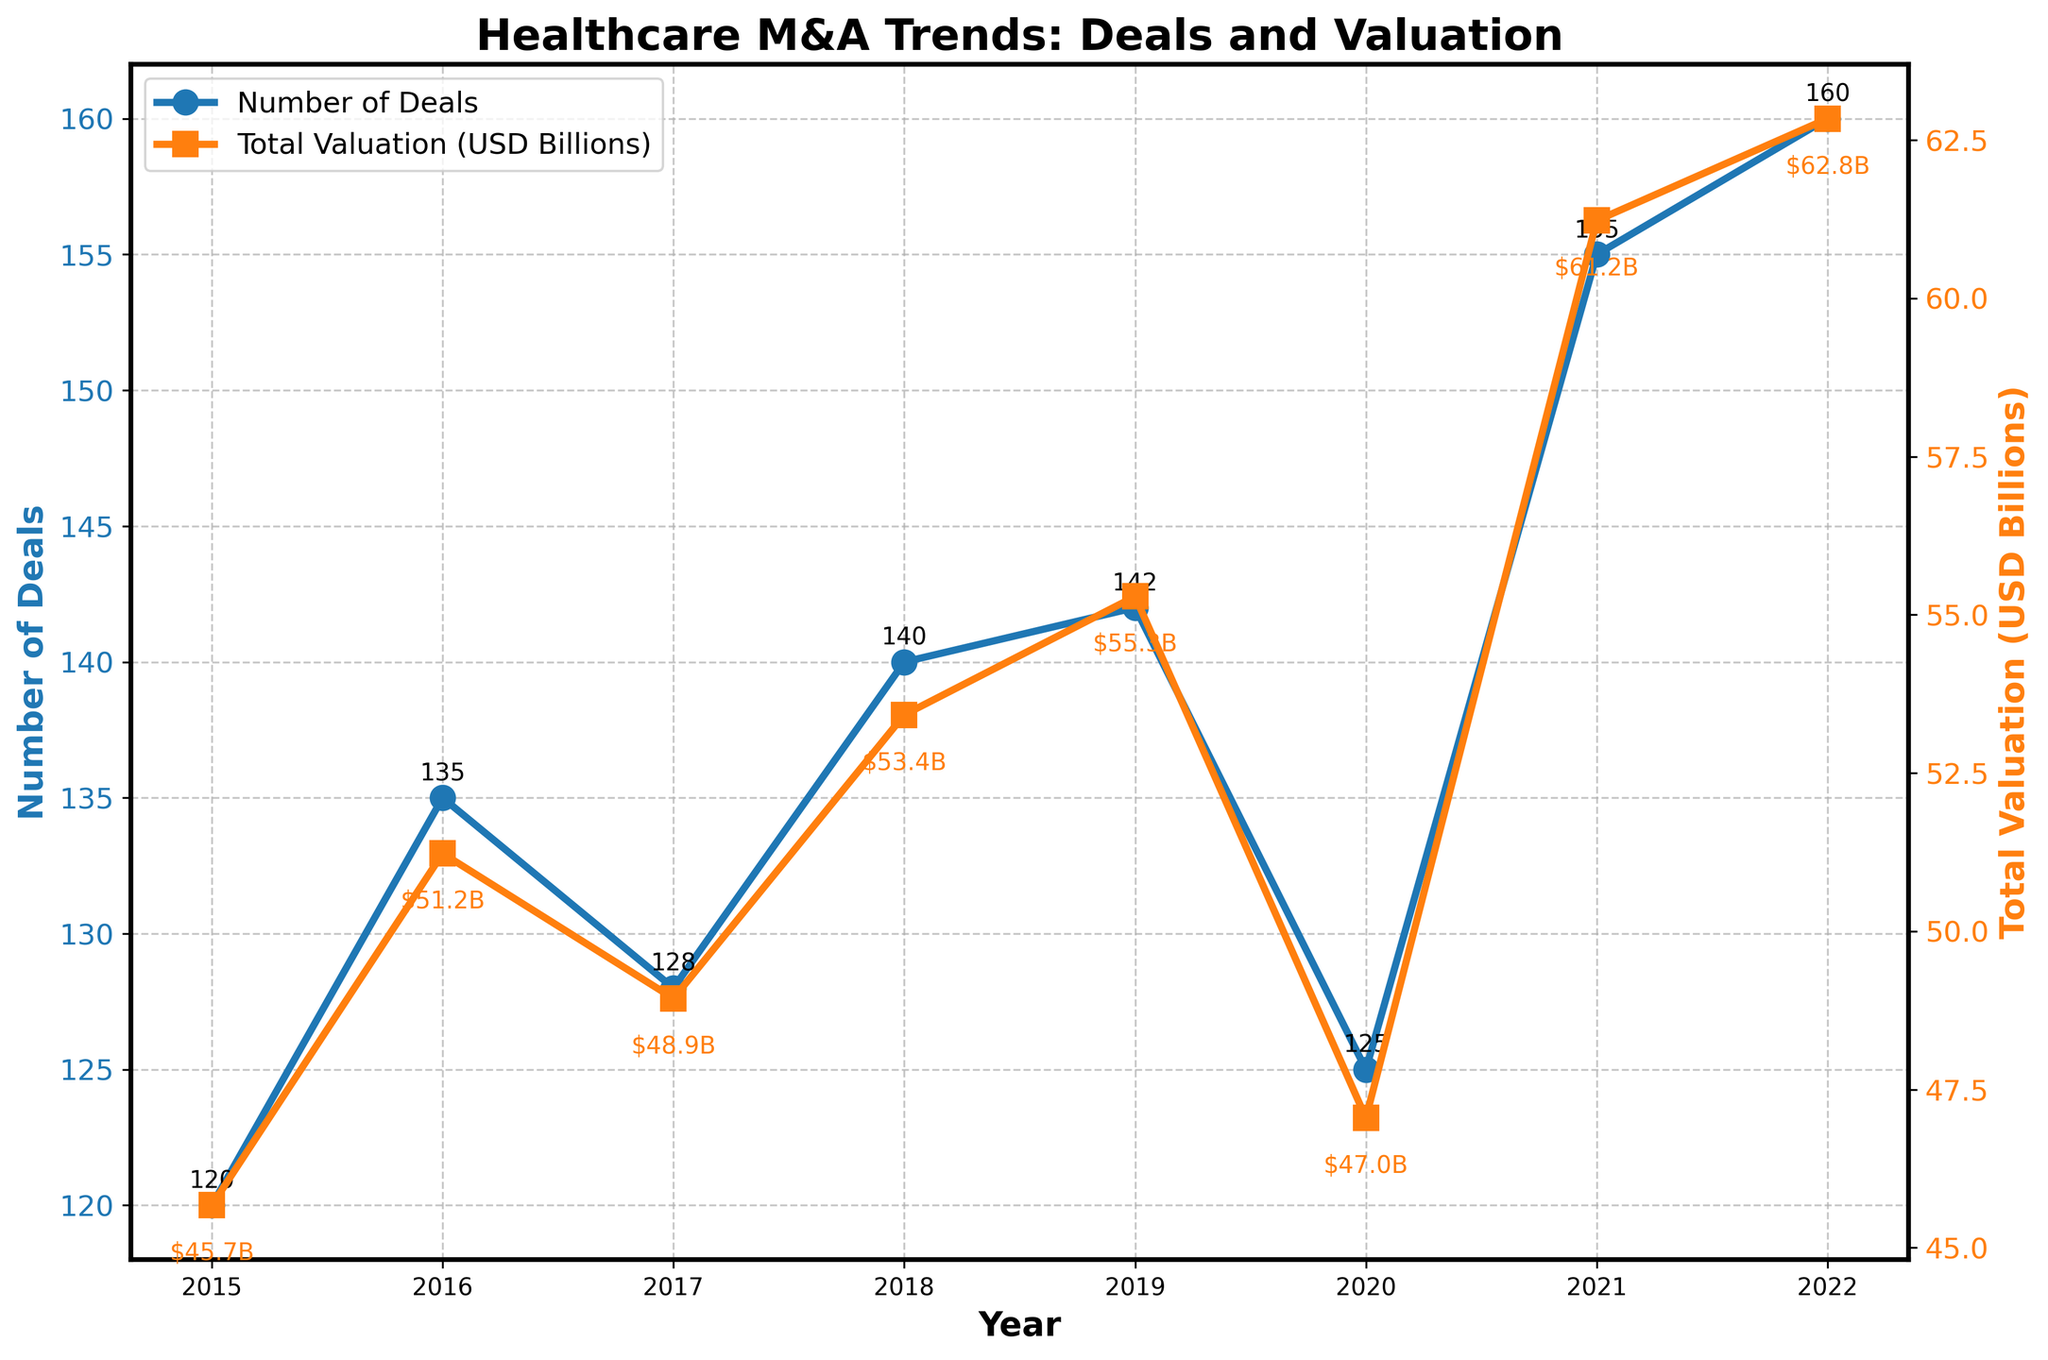What are the titles of the x-axis and y-axes in the plot? The x-axis title is indicated as "Year" reflecting the timespan of the data. The y-axis titles are "Number of Deals" for the left axis and "Total Valuation (USD Billions)" for the right axis, showing the respective quantities they represent over time.
Answer: Year, Number of Deals, Total Valuation (USD Billions) How many data points are plotted for each variable? Each year from 2015 to 2022 has data plotted, which totals 8 data points for both the Number of Deals and the Total Valuation.
Answer: 8 data points What is the trend of the Number of Deals between 2015 and 2022? To identify the trend, observe the plotted line for Number of Deals from 2015 to 2022. The data shows a generally increasing trend with some fluctuations; it rises from 120 deals in 2015 to a peak of 160 deals in 2022.
Answer: Increasing trend What was the total valuation in USD billions in 2017? Look at the spot on the right y-axis for the year 2017. The annotation shows $48.94B, converted from the total valuation of $48.94 billion in 2017.
Answer: $48.94 billion Compare the Number of Deals between 2020 and 2021. Which year had more deals and by how much? Compare the Number of Deals in 2020 and 2021. There were 125 deals in 2020 and 155 deals in 2021. 2021 had more deals by 155 - 125 = 30 deals.
Answer: 2021 had 30 more deals How did the Total Valuation change from 2019 to 2020? Examine the Total Valuation data for 2019 and 2020. The valuation decreased from $55.29 billion in 2019 to $47.05 billion in 2020, resulting in a decrease of $55.29 billion - $47.05 billion = $8.24 billion.
Answer: Decreased by $8.24 billion What is the average number of deals per year from 2015 to 2022? To find the average, add the number of deals for each year from 2015 to 2022 and divide by the number of years, which is 8. (120 + 135 + 128 + 140 + 142 + 125 + 155 + 160) / 8 = 1255 / 8 = 156.25.
Answer: 156.25 Which year had the highest Total Valuation and what was the value? Identify the highest point on the Total Valuation curve. The peak is in 2022 with a valuation of $62.84 billion.
Answer: 2022, $62.84 billion What was the difference in the Number of Deals between the year with the maximum and minimum values? Identify the maximum (2022, 160 deals) and minimum (2015, 120 deals) values of the Number of Deals from the plot. The difference is 160 - 120 = 40 deals.
Answer: 40 deals 